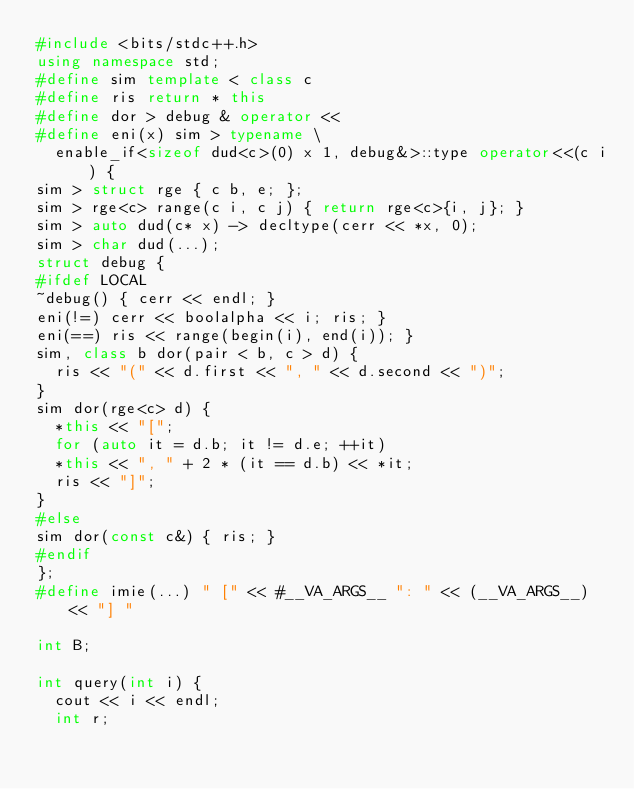<code> <loc_0><loc_0><loc_500><loc_500><_C++_>#include <bits/stdc++.h>
using namespace std;
#define sim template < class c
#define ris return * this
#define dor > debug & operator <<
#define eni(x) sim > typename \
  enable_if<sizeof dud<c>(0) x 1, debug&>::type operator<<(c i) {
sim > struct rge { c b, e; };
sim > rge<c> range(c i, c j) { return rge<c>{i, j}; }
sim > auto dud(c* x) -> decltype(cerr << *x, 0);
sim > char dud(...);
struct debug {
#ifdef LOCAL
~debug() { cerr << endl; }
eni(!=) cerr << boolalpha << i; ris; }
eni(==) ris << range(begin(i), end(i)); }
sim, class b dor(pair < b, c > d) {
  ris << "(" << d.first << ", " << d.second << ")";
}
sim dor(rge<c> d) {
  *this << "[";
  for (auto it = d.b; it != d.e; ++it)
	*this << ", " + 2 * (it == d.b) << *it;
  ris << "]";
}
#else
sim dor(const c&) { ris; }
#endif
};
#define imie(...) " [" << #__VA_ARGS__ ": " << (__VA_ARGS__) << "] "

int B;

int query(int i) {
	cout << i << endl;
	int r;</code> 